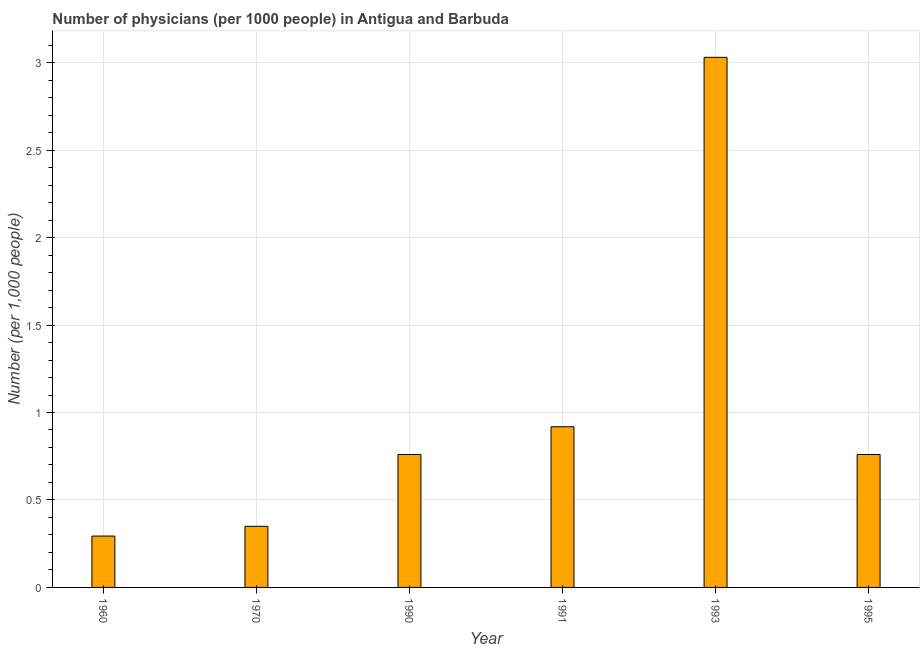Does the graph contain any zero values?
Make the answer very short. No. What is the title of the graph?
Make the answer very short. Number of physicians (per 1000 people) in Antigua and Barbuda. What is the label or title of the X-axis?
Offer a very short reply. Year. What is the label or title of the Y-axis?
Provide a short and direct response. Number (per 1,0 people). What is the number of physicians in 1991?
Ensure brevity in your answer.  0.92. Across all years, what is the maximum number of physicians?
Your response must be concise. 3.03. Across all years, what is the minimum number of physicians?
Give a very brief answer. 0.29. In which year was the number of physicians maximum?
Make the answer very short. 1993. What is the sum of the number of physicians?
Provide a succinct answer. 6.11. What is the difference between the number of physicians in 1960 and 1991?
Offer a very short reply. -0.62. What is the median number of physicians?
Make the answer very short. 0.76. In how many years, is the number of physicians greater than 1.5 ?
Offer a terse response. 1. Do a majority of the years between 1991 and 1995 (inclusive) have number of physicians greater than 2.8 ?
Give a very brief answer. No. Is the number of physicians in 1960 less than that in 1993?
Ensure brevity in your answer.  Yes. Is the difference between the number of physicians in 1960 and 1995 greater than the difference between any two years?
Offer a very short reply. No. What is the difference between the highest and the second highest number of physicians?
Ensure brevity in your answer.  2.11. Is the sum of the number of physicians in 1970 and 1993 greater than the maximum number of physicians across all years?
Provide a short and direct response. Yes. What is the difference between the highest and the lowest number of physicians?
Offer a terse response. 2.74. Are all the bars in the graph horizontal?
Make the answer very short. No. How many years are there in the graph?
Provide a succinct answer. 6. Are the values on the major ticks of Y-axis written in scientific E-notation?
Keep it short and to the point. No. What is the Number (per 1,000 people) of 1960?
Provide a succinct answer. 0.29. What is the Number (per 1,000 people) in 1970?
Offer a terse response. 0.35. What is the Number (per 1,000 people) of 1990?
Offer a terse response. 0.76. What is the Number (per 1,000 people) of 1991?
Make the answer very short. 0.92. What is the Number (per 1,000 people) of 1993?
Make the answer very short. 3.03. What is the Number (per 1,000 people) of 1995?
Make the answer very short. 0.76. What is the difference between the Number (per 1,000 people) in 1960 and 1970?
Your answer should be compact. -0.06. What is the difference between the Number (per 1,000 people) in 1960 and 1990?
Keep it short and to the point. -0.47. What is the difference between the Number (per 1,000 people) in 1960 and 1991?
Make the answer very short. -0.62. What is the difference between the Number (per 1,000 people) in 1960 and 1993?
Your answer should be very brief. -2.74. What is the difference between the Number (per 1,000 people) in 1960 and 1995?
Offer a terse response. -0.47. What is the difference between the Number (per 1,000 people) in 1970 and 1990?
Your response must be concise. -0.41. What is the difference between the Number (per 1,000 people) in 1970 and 1991?
Provide a succinct answer. -0.57. What is the difference between the Number (per 1,000 people) in 1970 and 1993?
Offer a terse response. -2.68. What is the difference between the Number (per 1,000 people) in 1970 and 1995?
Ensure brevity in your answer.  -0.41. What is the difference between the Number (per 1,000 people) in 1990 and 1991?
Your answer should be very brief. -0.16. What is the difference between the Number (per 1,000 people) in 1990 and 1993?
Make the answer very short. -2.27. What is the difference between the Number (per 1,000 people) in 1990 and 1995?
Make the answer very short. -0. What is the difference between the Number (per 1,000 people) in 1991 and 1993?
Make the answer very short. -2.11. What is the difference between the Number (per 1,000 people) in 1991 and 1995?
Your answer should be very brief. 0.16. What is the difference between the Number (per 1,000 people) in 1993 and 1995?
Provide a succinct answer. 2.27. What is the ratio of the Number (per 1,000 people) in 1960 to that in 1970?
Keep it short and to the point. 0.84. What is the ratio of the Number (per 1,000 people) in 1960 to that in 1990?
Give a very brief answer. 0.39. What is the ratio of the Number (per 1,000 people) in 1960 to that in 1991?
Provide a succinct answer. 0.32. What is the ratio of the Number (per 1,000 people) in 1960 to that in 1993?
Your response must be concise. 0.1. What is the ratio of the Number (per 1,000 people) in 1960 to that in 1995?
Offer a very short reply. 0.39. What is the ratio of the Number (per 1,000 people) in 1970 to that in 1990?
Provide a succinct answer. 0.46. What is the ratio of the Number (per 1,000 people) in 1970 to that in 1991?
Provide a short and direct response. 0.38. What is the ratio of the Number (per 1,000 people) in 1970 to that in 1993?
Offer a terse response. 0.12. What is the ratio of the Number (per 1,000 people) in 1970 to that in 1995?
Make the answer very short. 0.46. What is the ratio of the Number (per 1,000 people) in 1990 to that in 1991?
Keep it short and to the point. 0.83. What is the ratio of the Number (per 1,000 people) in 1990 to that in 1993?
Give a very brief answer. 0.25. What is the ratio of the Number (per 1,000 people) in 1991 to that in 1993?
Ensure brevity in your answer.  0.3. What is the ratio of the Number (per 1,000 people) in 1991 to that in 1995?
Offer a very short reply. 1.21. What is the ratio of the Number (per 1,000 people) in 1993 to that in 1995?
Offer a very short reply. 3.99. 